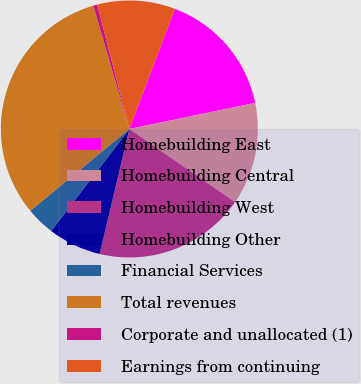Convert chart to OTSL. <chart><loc_0><loc_0><loc_500><loc_500><pie_chart><fcel>Homebuilding East<fcel>Homebuilding Central<fcel>Homebuilding West<fcel>Homebuilding Other<fcel>Financial Services<fcel>Total revenues<fcel>Corporate and unallocated (1)<fcel>Earnings from continuing<nl><fcel>15.98%<fcel>12.89%<fcel>19.08%<fcel>6.7%<fcel>3.6%<fcel>31.46%<fcel>0.5%<fcel>9.79%<nl></chart> 